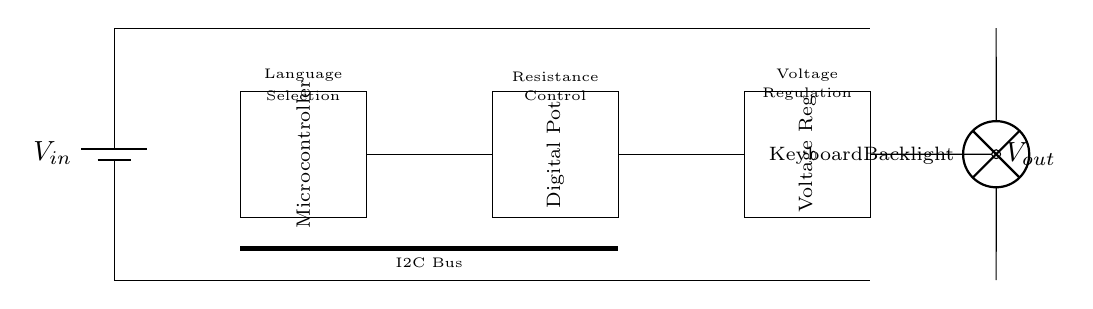What component represents the power supply in the circuit? The power supply in the circuit is represented by the battery symbol on the left side, labeled as V in.
Answer: V in What is the role of the microcontroller in this circuit? The microcontroller is used to control language selection and potentially manage the digital potentiometer for backlight intensity.
Answer: Control What does the digital potentiometer control in this circuit? The digital potentiometer is used for adjusting the resistance, which influences the brightness of the keyboard backlight.
Answer: Brightness What is the purpose of the voltage regulator in this circuit? The voltage regulator ensures that the output voltage remains stable and appropriate for the components connected to it.
Answer: Stabilization How do the components communicate in this circuit? The components communicate via the I2C bus, which is indicated by the thick line connecting the microcontroller to the digital potentiometer.
Answer: I2C bus What is the output voltage designated as in the circuit? The output voltage is designated as V out, which is noted as the terminal leading to the keyboard backlight.
Answer: V out What does the lamp represent in the diagram? The lamp represents the keyboard backlight, which is powered by the output of the voltage regulator.
Answer: Keyboard Backlight 